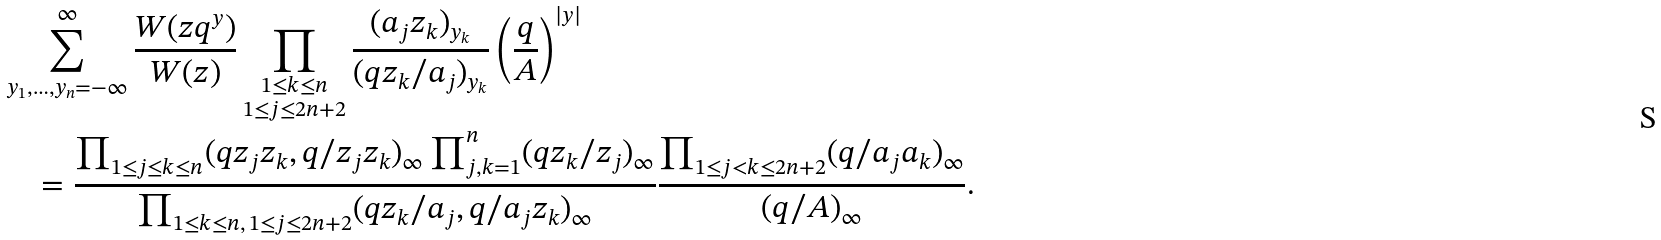<formula> <loc_0><loc_0><loc_500><loc_500>& \sum _ { y _ { 1 } , \dots , y _ { n } = - \infty } ^ { \infty } \frac { W ( z q ^ { y } ) } { W ( z ) } \prod _ { \substack { 1 \leq k \leq n \\ 1 \leq j \leq 2 n + 2 } } \frac { ( a _ { j } z _ { k } ) _ { y _ { k } } } { ( q z _ { k } / a _ { j } ) _ { y _ { k } } } \left ( \frac { q } { A } \right ) ^ { | y | } \\ & \quad = \frac { \prod _ { 1 \leq j \leq k \leq n } ( q z _ { j } z _ { k } , q / z _ { j } z _ { k } ) _ { \infty } \prod _ { j , k = 1 } ^ { n } ( q z _ { k } / z _ { j } ) _ { \infty } } { \prod _ { 1 \leq k \leq n , \, 1 \leq j \leq 2 n + 2 } ( q z _ { k } / a _ { j } , q / a _ { j } z _ { k } ) _ { \infty } } \frac { \prod _ { 1 \leq j < k \leq 2 n + 2 } ( q / a _ { j } a _ { k } ) _ { \infty } } { ( q / A ) _ { \infty } } .</formula> 